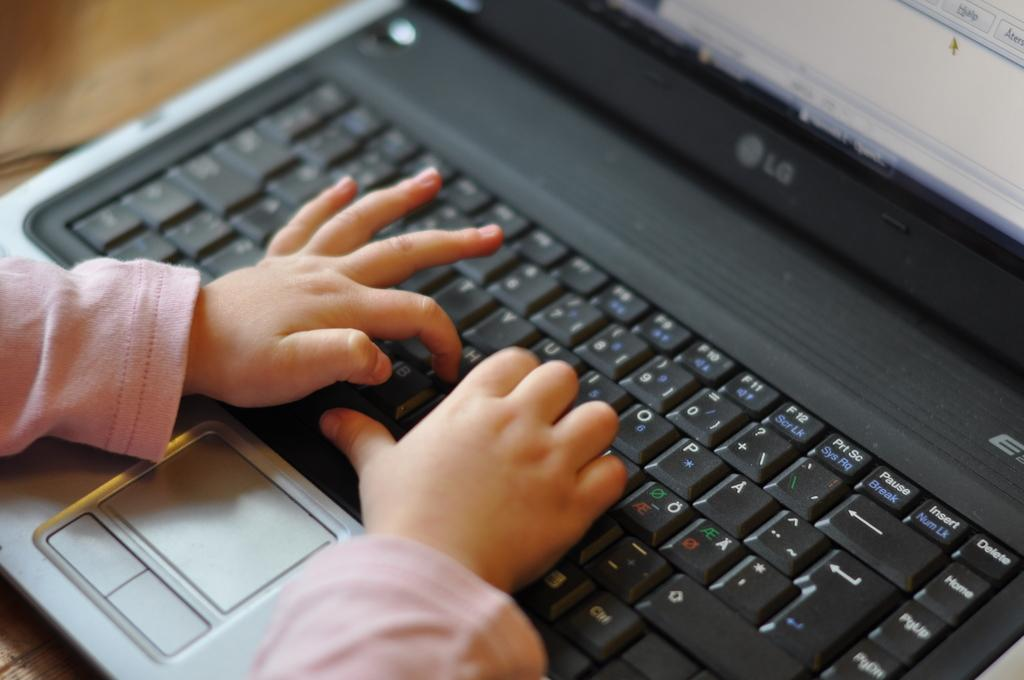<image>
Present a compact description of the photo's key features. A child presses the H key as they type on an LG laptop. 